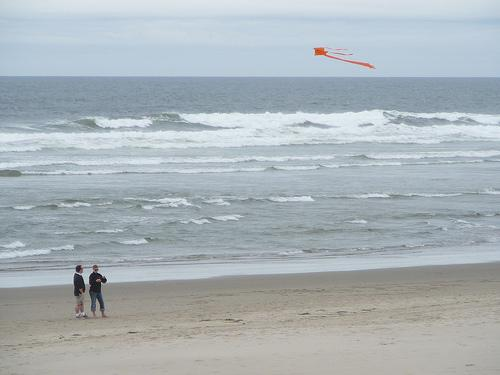What activity are the two people engaged in on this beach? The two people are standing together on the beach, engaged in a discussion and possibly flying the orange kite. Examine the water in the image and describe its characteristics. The water in the image appears white and choppy with heavy waves flowing onto the beach, and it showcases a wave coming into the shore with a crest. Based on the image data, what is happening at the seashore in the image? There are two people standing together on the beach, likely having a discussion and possibly flying an orange kite, while waves flow onto the beach, and the sky presents a mixed color palette of blue and grey with thick clouds. Can you give a vivid description of the scene in the image? This image showcases a couple enjoying their beach day by flying an orange kite with tails in the air, while standing on the light brown sand. The sky is a mixture of blue and grey with thick clouds, and the ocean presents choppy waves and white water. How many people are standing together on the beach, according to the image data? There are two people standing together on the beach. Comment on the emotional atmosphere captured in this photograph. The image portrays a relaxed and pleasant atmosphere, with a couple casually dressed and engaged in an activity or discussion, enjoying their time on the beach. In this image, describe the clothing worn by the man and the woman on the beach. The man is wearing a white pair of socks, khaki shorts, and possibly a black sweater, while the woman is dressed in dark glasses, a black sweater, a pair of blue jean capris, and possibly a dark hair. What kind of kite can be seen in this image and what is its color? The kite is an orange kite with tails in action, and it has one long tail and two shorter tails. Identify the colors of the sky and sea in the image. The sky is a mix of blue and grey colors, while the sea appears to be white and choppy due to heavy waves. What are the main objects visible in this picture and their characteristics? The main objects in this picture are two people dressed casually, an orange kite with streamers, a body of water with waves, and light brown sand with few tracks. The sky shows blue and grey colors along with thick clouds. 